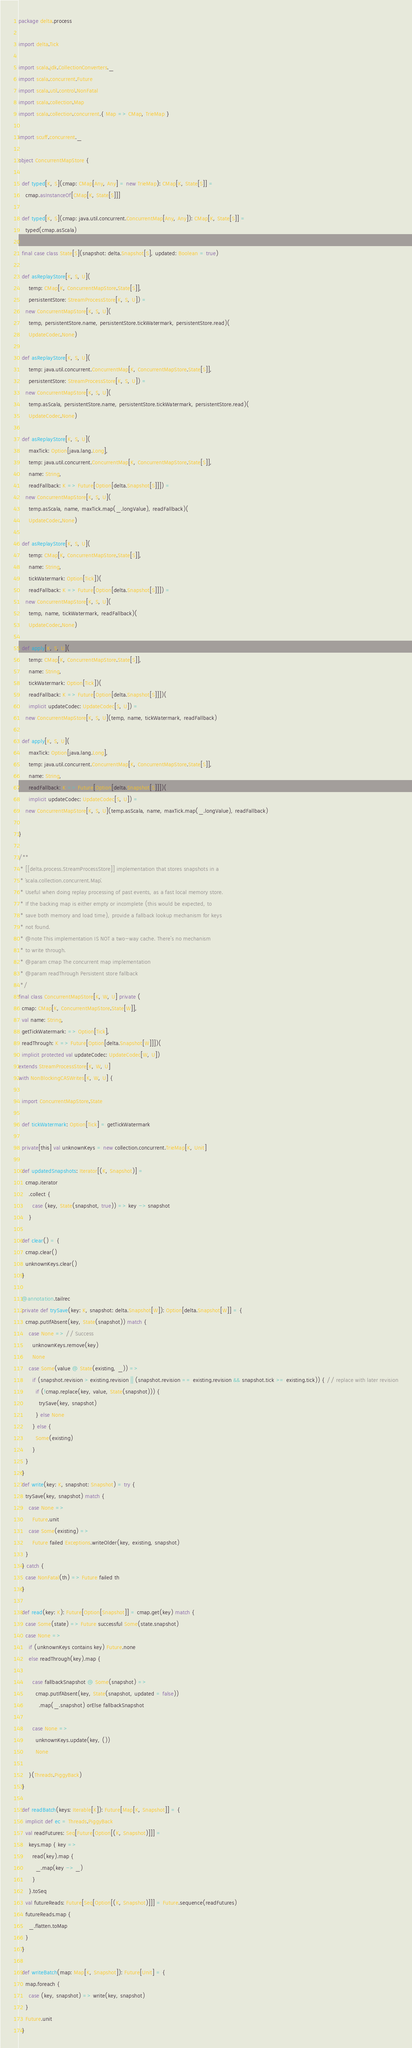<code> <loc_0><loc_0><loc_500><loc_500><_Scala_>package delta.process

import delta.Tick

import scala.jdk.CollectionConverters._
import scala.concurrent.Future
import scala.util.control.NonFatal
import scala.collection.Map
import scala.collection.concurrent.{ Map => CMap, TrieMap }

import scuff.concurrent._

object ConcurrentMapStore {

  def typed[K, S](cmap: CMap[Any, Any] = new TrieMap): CMap[K, State[S]] =
    cmap.asInstanceOf[CMap[K, State[S]]]

  def typed[K, S](cmap: java.util.concurrent.ConcurrentMap[Any, Any]): CMap[K, State[S]] =
    typed(cmap.asScala)

  final case class State[S](snapshot: delta.Snapshot[S], updated: Boolean = true)

  def asReplayStore[K, S, U](
      temp: CMap[K, ConcurrentMapStore.State[S]],
      persistentStore: StreamProcessStore[K, S, U]) =
    new ConcurrentMapStore[K, S, U](
      temp, persistentStore.name, persistentStore.tickWatermark, persistentStore.read)(
      UpdateCodec.None)

  def asReplayStore[K, S, U](
      temp: java.util.concurrent.ConcurrentMap[K, ConcurrentMapStore.State[S]],
      persistentStore: StreamProcessStore[K, S, U]) =
    new ConcurrentMapStore[K, S, U](
      temp.asScala, persistentStore.name, persistentStore.tickWatermark, persistentStore.read)(
      UpdateCodec.None)

  def asReplayStore[K, S, U](
      maxTick: Option[java.lang.Long],
      temp: java.util.concurrent.ConcurrentMap[K, ConcurrentMapStore.State[S]],
      name: String,
      readFallback: K => Future[Option[delta.Snapshot[S]]]) =
    new ConcurrentMapStore[K, S, U](
      temp.asScala, name, maxTick.map(_.longValue), readFallback)(
      UpdateCodec.None)

  def asReplayStore[K, S, U](
      temp: CMap[K, ConcurrentMapStore.State[S]],
      name: String,
      tickWatermark: Option[Tick])(
      readFallback: K => Future[Option[delta.Snapshot[S]]]) =
    new ConcurrentMapStore[K, S, U](
      temp, name, tickWatermark, readFallback)(
      UpdateCodec.None)

  def apply[K, S, U](
      temp: CMap[K, ConcurrentMapStore.State[S]],
      name: String,
      tickWatermark: Option[Tick])(
      readFallback: K => Future[Option[delta.Snapshot[S]]])(
      implicit updateCodec: UpdateCodec[S, U]) =
    new ConcurrentMapStore[K, S, U](temp, name, tickWatermark, readFallback)

  def apply[K, S, U](
      maxTick: Option[java.lang.Long],
      temp: java.util.concurrent.ConcurrentMap[K, ConcurrentMapStore.State[S]],
      name: String,
      readFallback: K => Future[Option[delta.Snapshot[S]]])(
      implicit updateCodec: UpdateCodec[S, U]) =
    new ConcurrentMapStore[K, S, U](temp.asScala, name, maxTick.map(_.longValue), readFallback)

}

/**
 * [[delta.process.StreamProcessStore]] implementation that stores snapshots in a
 * `scala.collection.concurrent.Map`.
 * Useful when doing replay processing of past events, as a fast local memory store.
 * If the backing map is either empty or incomplete (this would be expected, to
 * save both memory and load time), provide a fallback lookup mechanism for keys
 * not found.
 * @note This implementation IS NOT a two-way cache. There's no mechanism
 * to write through.
 * @param cmap The concurrent map implementation
 * @param readThrough Persistent store fallback
 */
final class ConcurrentMapStore[K, W, U] private (
  cmap: CMap[K, ConcurrentMapStore.State[W]],
  val name: String,
  getTickWatermark: => Option[Tick],
  readThrough: K => Future[Option[delta.Snapshot[W]]])(
  implicit protected val updateCodec: UpdateCodec[W, U])
extends StreamProcessStore[K, W, U]
with NonBlockingCASWrites[K, W, U] {

  import ConcurrentMapStore.State

  def tickWatermark: Option[Tick] = getTickWatermark

  private[this] val unknownKeys = new collection.concurrent.TrieMap[K, Unit]

  def updatedSnapshots: Iterator[(K, Snapshot)] =
    cmap.iterator
      .collect {
        case (key, State(snapshot, true)) => key -> snapshot
      }

  def clear() = {
    cmap.clear()
    unknownKeys.clear()
  }

  @annotation.tailrec
  private def trySave(key: K, snapshot: delta.Snapshot[W]): Option[delta.Snapshot[W]] = {
    cmap.putIfAbsent(key, State(snapshot)) match {
      case None => // Success
        unknownKeys.remove(key)
        None
      case Some(value @ State(existing, _)) =>
        if (snapshot.revision > existing.revision || (snapshot.revision == existing.revision && snapshot.tick >= existing.tick)) { // replace with later revision
          if (!cmap.replace(key, value, State(snapshot))) {
            trySave(key, snapshot)
          } else None
        } else {
          Some(existing)
        }
    }
  }
  def write(key: K, snapshot: Snapshot) = try {
    trySave(key, snapshot) match {
      case None =>
        Future.unit
      case Some(existing) =>
        Future failed Exceptions.writeOlder(key, existing, snapshot)
    }
  } catch {
    case NonFatal(th) => Future failed th
  }

  def read(key: K): Future[Option[Snapshot]] = cmap.get(key) match {
    case Some(state) => Future successful Some(state.snapshot)
    case None =>
      if (unknownKeys contains key) Future.none
      else readThrough(key).map {

        case fallbackSnapshot @ Some(snapshot) =>
          cmap.putIfAbsent(key, State(snapshot, updated = false))
            .map(_.snapshot) orElse fallbackSnapshot

        case None =>
          unknownKeys.update(key, ())
          None

      }(Threads.PiggyBack)
  }

  def readBatch(keys: Iterable[K]): Future[Map[K, Snapshot]] = {
    implicit def ec = Threads.PiggyBack
    val readFutures: Seq[Future[Option[(K, Snapshot)]]] =
      keys.map { key =>
        read(key).map {
          _.map(key -> _)
        }
      }.toSeq
    val futureReads: Future[Seq[Option[(K, Snapshot)]]] = Future.sequence(readFutures)
    futureReads.map {
      _.flatten.toMap
    }
  }

  def writeBatch(map: Map[K, Snapshot]): Future[Unit] = {
    map.foreach {
      case (key, snapshot) => write(key, snapshot)
    }
    Future.unit
  }</code> 